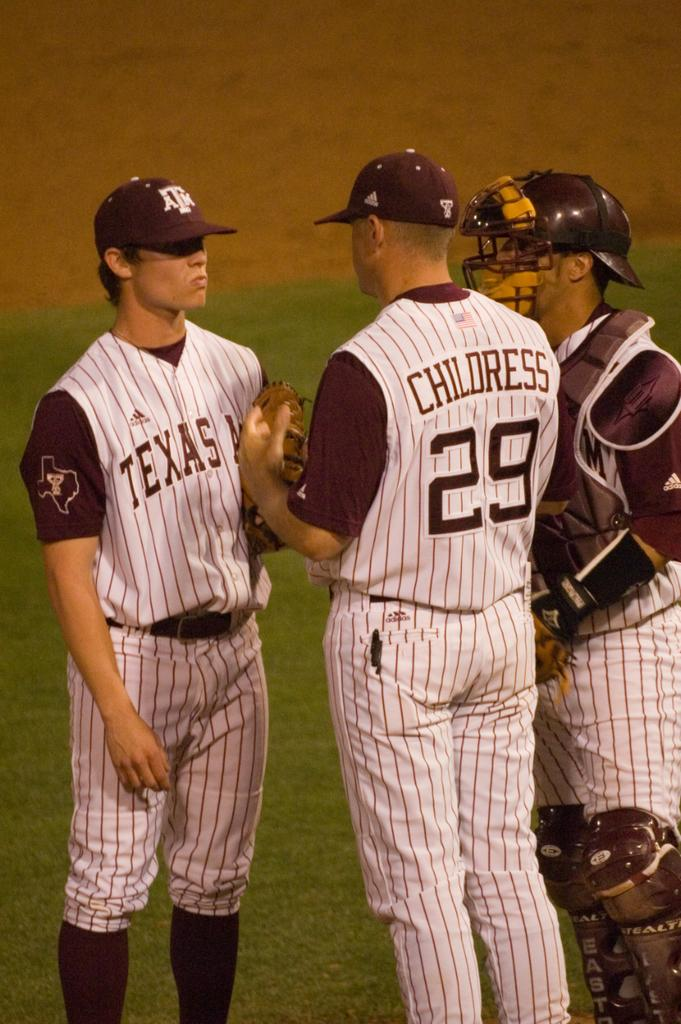<image>
Render a clear and concise summary of the photo. a few players and one with the name Childress on it 